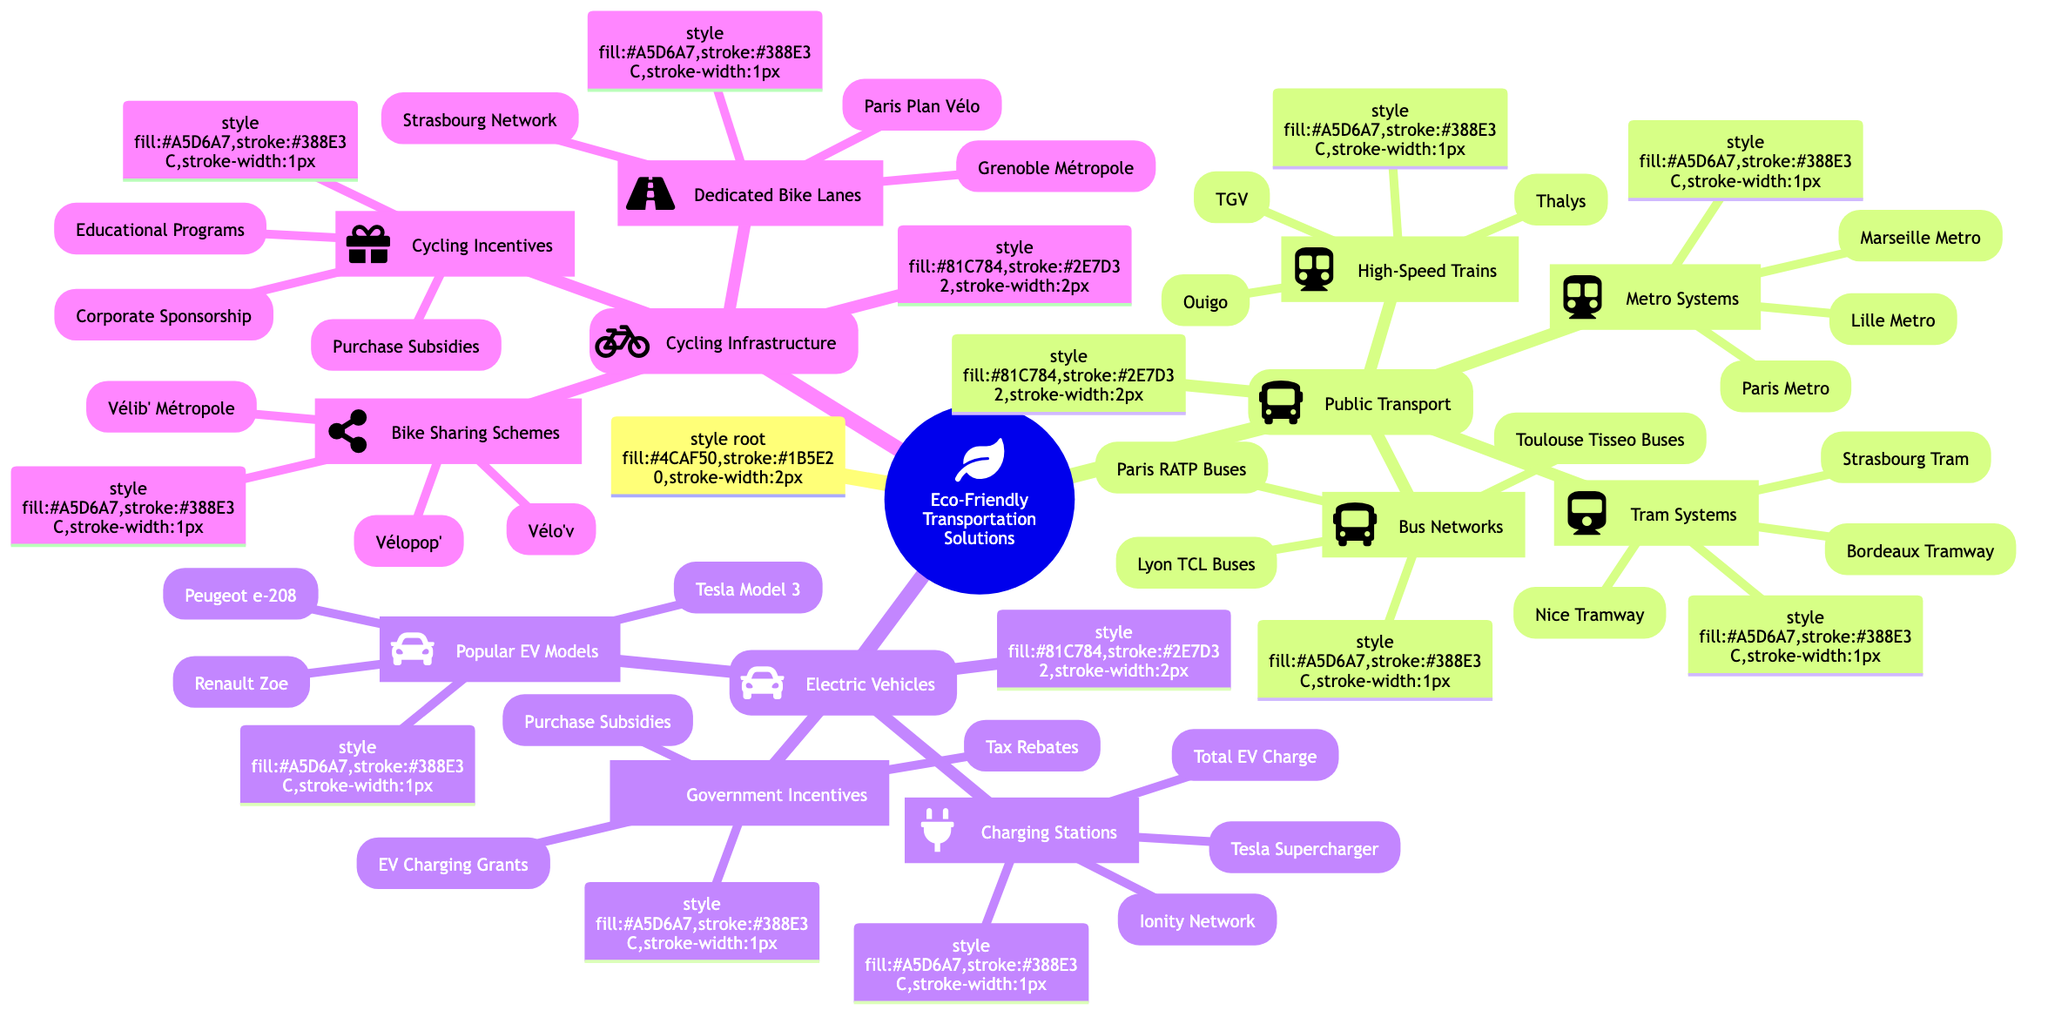What are the types of public transport listed? The main categories under public transport in the diagram are Tram Systems, Bus Networks, High-Speed Trains, and Metro Systems.
Answer: Tram Systems, Bus Networks, High-Speed Trains, Metro Systems How many bike sharing schemes are mentioned? In the cycling infrastructure section, there are three bike sharing schemes listed: Vélib' Métropole, Vélo'v, and Vélopop'.
Answer: 3 What are the names of the popular electric vehicle models? The popular electric vehicle models listed in the diagram include Renault Zoe, Peugeot e-208, and Tesla Model 3.
Answer: Renault Zoe, Peugeot e-208, Tesla Model 3 Which city has a tram system called "Vélo'v"? "Vélo'v" is a bike sharing scheme in Lyon, not a tram system. Instead, the tram systems mentioned are Nice Tramway, Strasbourg Tram, and Bordeaux Tramway.
Answer: Lyon What kind of incentives are provided for electric vehicles? The government incentives for electric vehicles include Purchase Subsidies, Tax Rebates, and EV Charging Infrastructure Grants.
Answer: Purchase Subsidies, Tax Rebates, EV Charging Grants What is the relationship between charging stations and electric vehicles? Charging stations form a critical component of the infrastructure that supports electric vehicles by providing necessary charging facilities. The relevant stations listed are Ionity Network, Tesla Supercharger, and Total EV Charge.
Answer: Supports charging needs Which type of infrastructure has a dedicated plan in Paris? The cycling infrastructure has a dedicated plan known as "Paris Plan Vélo," which is aimed at improving cycling in the city.
Answer: Paris Plan Vélo List the four major categories of eco-friendly transportation solutions. The four major categories in the diagram are Public Transport, Electric Vehicles, Cycling Infrastructure, and the overarching theme of Eco-Friendly Transportation Solutions.
Answer: Public Transport, Electric Vehicles, Cycling Infrastructure What city has the highest number of transport options mentioned? Paris is the city with the most transport options mentioned, including the Paris Metro, Paris RATP Buses, and Vélib' Métropole bike sharing scheme, illustrating comprehensive public and cycling transport.
Answer: Paris What are the types of incentives for cycling mentioned? The cycling incentives include Bike Purchase Subsidies, Corporate Cycling Sponsorship, and Educational Programs aimed at encouraging cycling in urban environments.
Answer: Bike Purchase Subsidies, Corporate Sponsorship, Educational Programs 